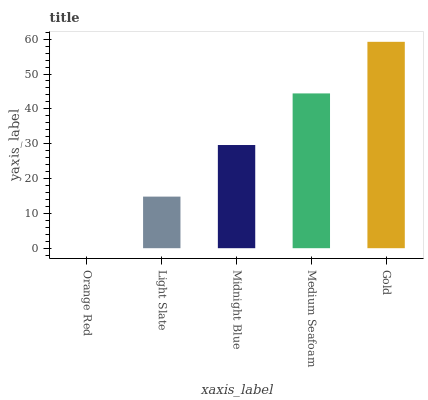Is Gold the maximum?
Answer yes or no. Yes. Is Light Slate the minimum?
Answer yes or no. No. Is Light Slate the maximum?
Answer yes or no. No. Is Light Slate greater than Orange Red?
Answer yes or no. Yes. Is Orange Red less than Light Slate?
Answer yes or no. Yes. Is Orange Red greater than Light Slate?
Answer yes or no. No. Is Light Slate less than Orange Red?
Answer yes or no. No. Is Midnight Blue the high median?
Answer yes or no. Yes. Is Midnight Blue the low median?
Answer yes or no. Yes. Is Medium Seafoam the high median?
Answer yes or no. No. Is Medium Seafoam the low median?
Answer yes or no. No. 